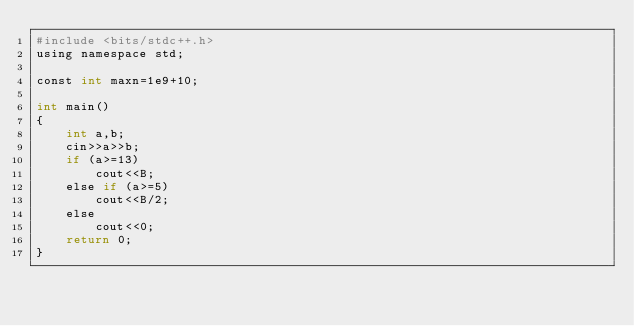Convert code to text. <code><loc_0><loc_0><loc_500><loc_500><_Awk_>#include <bits/stdc++.h>
using namespace std;

const int maxn=1e9+10;

int main()
{
	int a,b;
	cin>>a>>b;
	if (a>=13)
		cout<<B;
	else if (a>=5)
		cout<<B/2;
	else
		cout<<0;
	return 0;
}
</code> 